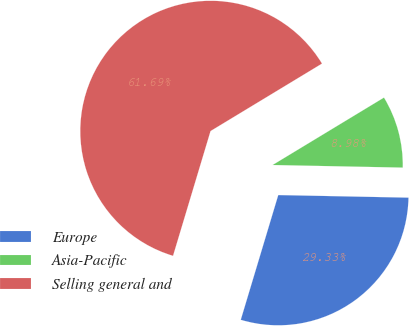Convert chart to OTSL. <chart><loc_0><loc_0><loc_500><loc_500><pie_chart><fcel>Europe<fcel>Asia-Pacific<fcel>Selling general and<nl><fcel>29.33%<fcel>8.98%<fcel>61.69%<nl></chart> 